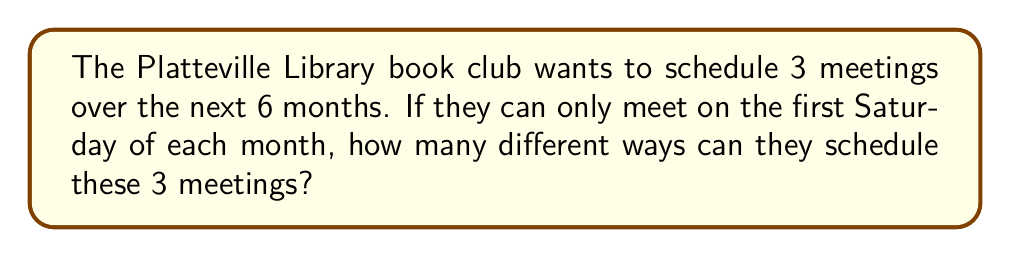Could you help me with this problem? Let's approach this step-by-step:

1) First, we need to identify what type of problem this is. This is a combination problem because the order of selecting the months doesn't matter (January, March, May is the same schedule as May, January, March).

2) We have 6 months to choose from (the next 6 months), and we need to choose 3 of them.

3) The formula for combinations is:

   $$C(n,r) = \frac{n!}{r!(n-r)!}$$

   Where $n$ is the total number of items to choose from, and $r$ is the number of items being chosen.

4) In this case, $n = 6$ (6 months) and $r = 3$ (3 meetings).

5) Let's plug these numbers into our formula:

   $$C(6,3) = \frac{6!}{3!(6-3)!} = \frac{6!}{3!3!}$$

6) Expand this:
   $$\frac{6 \times 5 \times 4 \times 3!}{3 \times 2 \times 1 \times 3!}$$

7) The 3! cancels out in the numerator and denominator:
   $$\frac{6 \times 5 \times 4}{3 \times 2 \times 1} = \frac{120}{6} = 20$$

Therefore, there are 20 different ways to schedule the 3 meetings over the next 6 months.
Answer: 20 